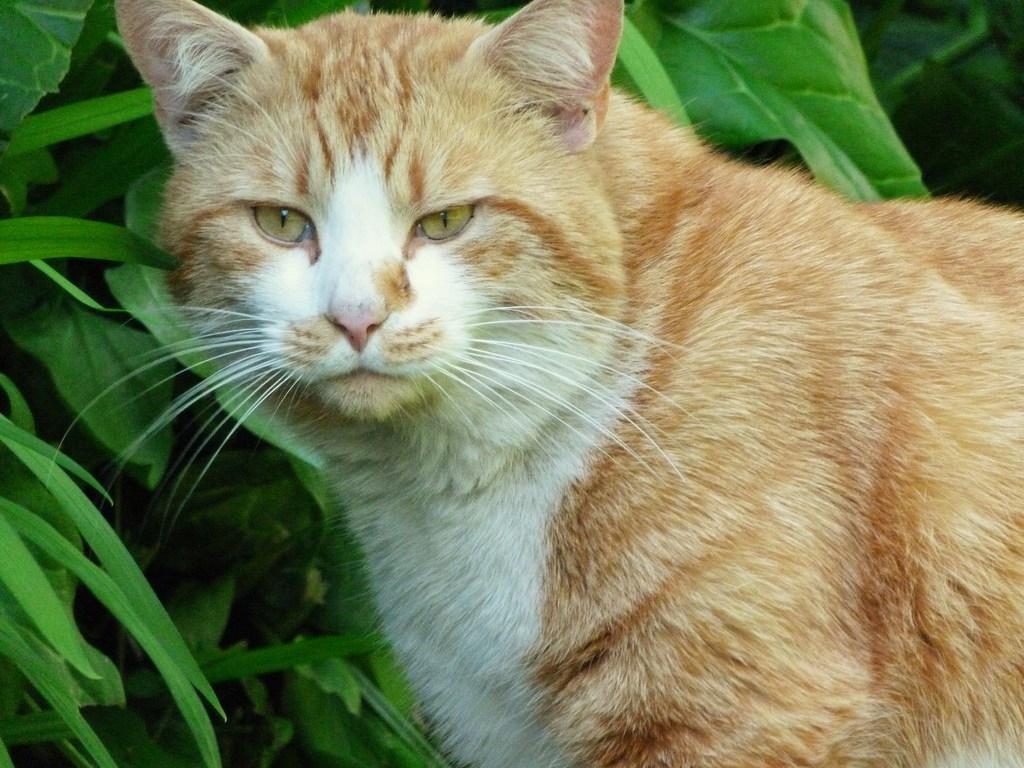Please provide a concise description of this image. In this image there is a cat truncated towards the right of the image, at the background of the image there are plants truncated. 